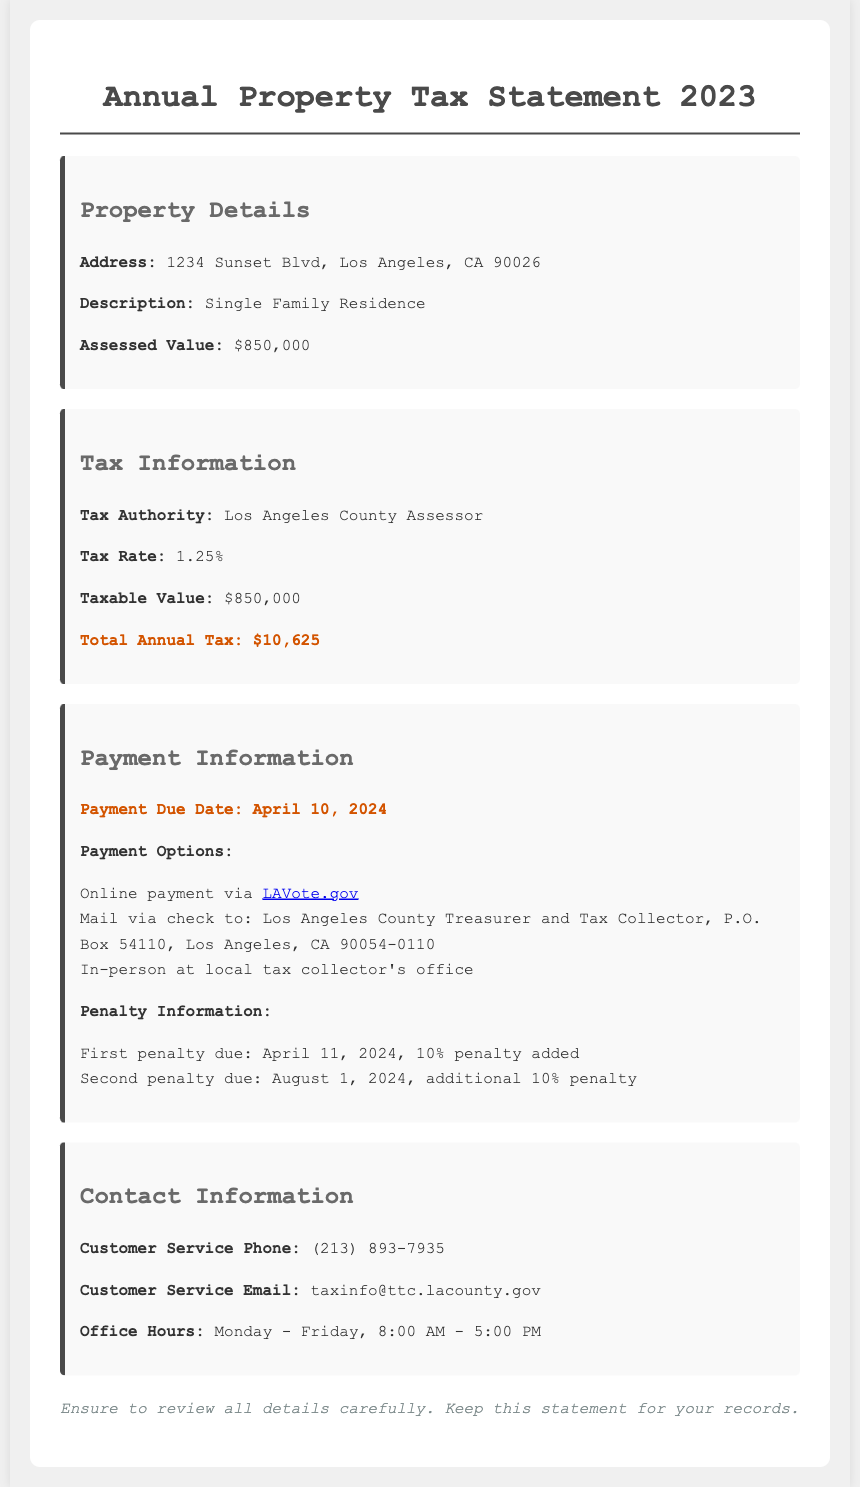What is the assessed value of the property? The assessed value is stated in the document as the value assigned to the property for tax purposes.
Answer: $850,000 What is the total annual tax? The total annual tax is the calculated tax amount based on the assessed value and tax rate.
Answer: $10,625 When is the payment due date? The payment due date is the date by which the tax payment must be received to avoid penalties.
Answer: April 10, 2024 What is the tax rate? The tax rate is a percentage used to calculate the property tax amount based on the assessed value.
Answer: 1.25% What are the penalty amounts if payment is late? The penalty amounts for late payment are specified as a percentage of the total tax due, as detailed in the penalties section.
Answer: 10% Who is the tax authority? The tax authority is the government body responsible for collecting taxes, which is identified in the document.
Answer: Los Angeles County Assessor What type of property is assessed? The document specifies the type of property for tax purposes, which provides important context for the assessed value.
Answer: Single Family Residence What are the payment options listed? The payment options are methods offered for making the tax payment, essential for understanding how to pay the tax.
Answer: Online payment, Mail via check, In-person at local tax collector's office What is the customer service phone number? The customer service phone number provides a direct line for inquiries related to property taxes, important for taxpayers needing assistance.
Answer: (213) 893-7935 